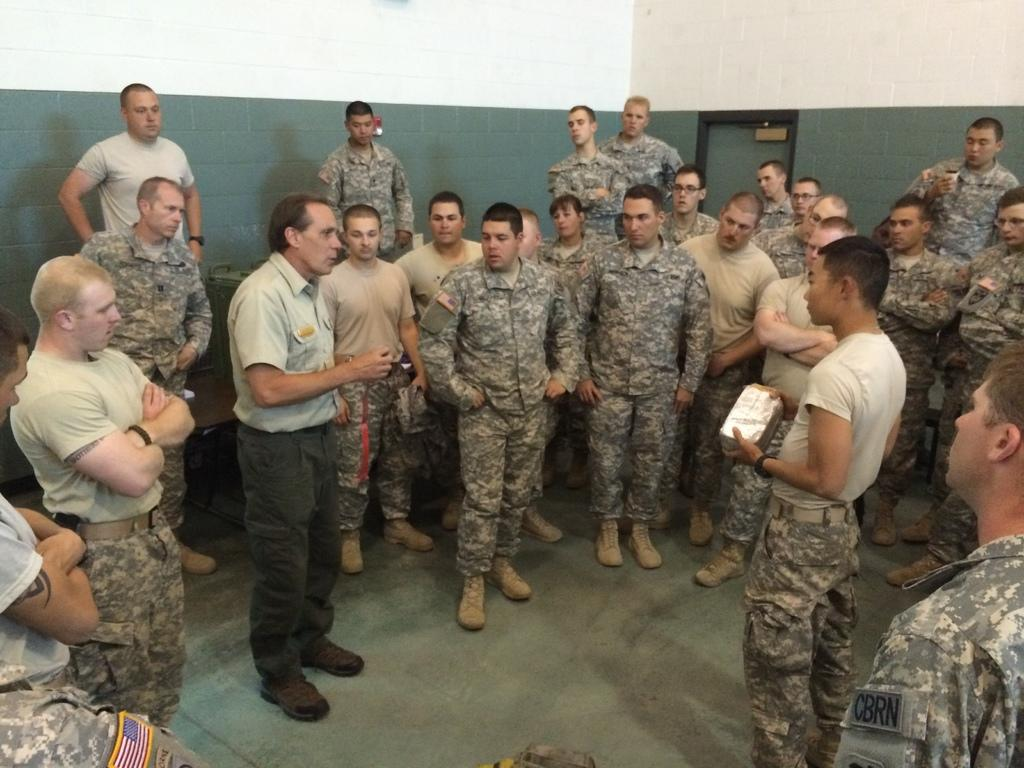What are the people in the image wearing? The men in the image are wearing army uniforms. What can be seen in the background of the image? There are white and green color walls in the background of the image. What type of ornament is hanging from the coast in the image? There is no coast or ornament present in the image. Are the men in the image driving any vehicles? No, the men in the image are not driving any vehicles; they are standing. 